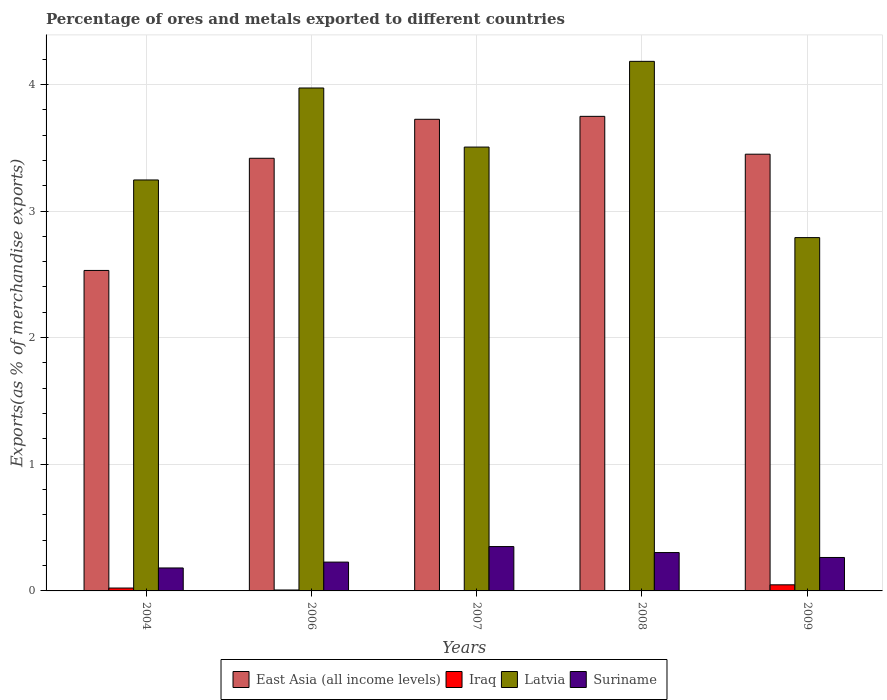How many different coloured bars are there?
Offer a very short reply. 4. What is the label of the 2nd group of bars from the left?
Offer a very short reply. 2006. What is the percentage of exports to different countries in Latvia in 2007?
Your response must be concise. 3.5. Across all years, what is the maximum percentage of exports to different countries in Suriname?
Your answer should be very brief. 0.35. Across all years, what is the minimum percentage of exports to different countries in Latvia?
Ensure brevity in your answer.  2.79. What is the total percentage of exports to different countries in East Asia (all income levels) in the graph?
Your answer should be compact. 16.87. What is the difference between the percentage of exports to different countries in Suriname in 2008 and that in 2009?
Keep it short and to the point. 0.04. What is the difference between the percentage of exports to different countries in Latvia in 2007 and the percentage of exports to different countries in Iraq in 2004?
Make the answer very short. 3.48. What is the average percentage of exports to different countries in East Asia (all income levels) per year?
Offer a terse response. 3.37. In the year 2006, what is the difference between the percentage of exports to different countries in Suriname and percentage of exports to different countries in Latvia?
Ensure brevity in your answer.  -3.74. What is the ratio of the percentage of exports to different countries in Suriname in 2006 to that in 2009?
Make the answer very short. 0.86. Is the percentage of exports to different countries in Latvia in 2007 less than that in 2009?
Your response must be concise. No. Is the difference between the percentage of exports to different countries in Suriname in 2007 and 2009 greater than the difference between the percentage of exports to different countries in Latvia in 2007 and 2009?
Offer a very short reply. No. What is the difference between the highest and the second highest percentage of exports to different countries in Iraq?
Your response must be concise. 0.03. What is the difference between the highest and the lowest percentage of exports to different countries in Latvia?
Your answer should be very brief. 1.39. What does the 1st bar from the left in 2009 represents?
Provide a succinct answer. East Asia (all income levels). What does the 4th bar from the right in 2009 represents?
Ensure brevity in your answer.  East Asia (all income levels). Is it the case that in every year, the sum of the percentage of exports to different countries in Iraq and percentage of exports to different countries in Latvia is greater than the percentage of exports to different countries in Suriname?
Provide a short and direct response. Yes. How many years are there in the graph?
Keep it short and to the point. 5. What is the difference between two consecutive major ticks on the Y-axis?
Give a very brief answer. 1. Does the graph contain any zero values?
Your response must be concise. No. How many legend labels are there?
Offer a terse response. 4. What is the title of the graph?
Offer a very short reply. Percentage of ores and metals exported to different countries. Does "Armenia" appear as one of the legend labels in the graph?
Keep it short and to the point. No. What is the label or title of the Y-axis?
Ensure brevity in your answer.  Exports(as % of merchandise exports). What is the Exports(as % of merchandise exports) in East Asia (all income levels) in 2004?
Offer a terse response. 2.53. What is the Exports(as % of merchandise exports) of Iraq in 2004?
Your response must be concise. 0.02. What is the Exports(as % of merchandise exports) in Latvia in 2004?
Give a very brief answer. 3.25. What is the Exports(as % of merchandise exports) in Suriname in 2004?
Your answer should be very brief. 0.18. What is the Exports(as % of merchandise exports) of East Asia (all income levels) in 2006?
Give a very brief answer. 3.42. What is the Exports(as % of merchandise exports) of Iraq in 2006?
Provide a short and direct response. 0.01. What is the Exports(as % of merchandise exports) of Latvia in 2006?
Your answer should be compact. 3.97. What is the Exports(as % of merchandise exports) of Suriname in 2006?
Give a very brief answer. 0.23. What is the Exports(as % of merchandise exports) of East Asia (all income levels) in 2007?
Offer a terse response. 3.72. What is the Exports(as % of merchandise exports) in Iraq in 2007?
Offer a very short reply. 9.249905308592759e-5. What is the Exports(as % of merchandise exports) of Latvia in 2007?
Provide a short and direct response. 3.5. What is the Exports(as % of merchandise exports) in Suriname in 2007?
Your answer should be very brief. 0.35. What is the Exports(as % of merchandise exports) in East Asia (all income levels) in 2008?
Your response must be concise. 3.75. What is the Exports(as % of merchandise exports) in Iraq in 2008?
Your response must be concise. 0. What is the Exports(as % of merchandise exports) of Latvia in 2008?
Your response must be concise. 4.18. What is the Exports(as % of merchandise exports) of Suriname in 2008?
Make the answer very short. 0.3. What is the Exports(as % of merchandise exports) in East Asia (all income levels) in 2009?
Your answer should be very brief. 3.45. What is the Exports(as % of merchandise exports) of Iraq in 2009?
Keep it short and to the point. 0.05. What is the Exports(as % of merchandise exports) in Latvia in 2009?
Provide a short and direct response. 2.79. What is the Exports(as % of merchandise exports) of Suriname in 2009?
Ensure brevity in your answer.  0.26. Across all years, what is the maximum Exports(as % of merchandise exports) of East Asia (all income levels)?
Give a very brief answer. 3.75. Across all years, what is the maximum Exports(as % of merchandise exports) of Iraq?
Offer a terse response. 0.05. Across all years, what is the maximum Exports(as % of merchandise exports) of Latvia?
Ensure brevity in your answer.  4.18. Across all years, what is the maximum Exports(as % of merchandise exports) of Suriname?
Your answer should be compact. 0.35. Across all years, what is the minimum Exports(as % of merchandise exports) in East Asia (all income levels)?
Keep it short and to the point. 2.53. Across all years, what is the minimum Exports(as % of merchandise exports) of Iraq?
Your answer should be very brief. 9.249905308592759e-5. Across all years, what is the minimum Exports(as % of merchandise exports) of Latvia?
Provide a short and direct response. 2.79. Across all years, what is the minimum Exports(as % of merchandise exports) of Suriname?
Your answer should be very brief. 0.18. What is the total Exports(as % of merchandise exports) of East Asia (all income levels) in the graph?
Provide a short and direct response. 16.87. What is the total Exports(as % of merchandise exports) of Iraq in the graph?
Your answer should be very brief. 0.08. What is the total Exports(as % of merchandise exports) of Latvia in the graph?
Provide a short and direct response. 17.69. What is the total Exports(as % of merchandise exports) in Suriname in the graph?
Your answer should be very brief. 1.33. What is the difference between the Exports(as % of merchandise exports) of East Asia (all income levels) in 2004 and that in 2006?
Offer a terse response. -0.89. What is the difference between the Exports(as % of merchandise exports) in Iraq in 2004 and that in 2006?
Give a very brief answer. 0.02. What is the difference between the Exports(as % of merchandise exports) of Latvia in 2004 and that in 2006?
Your response must be concise. -0.73. What is the difference between the Exports(as % of merchandise exports) of Suriname in 2004 and that in 2006?
Your answer should be very brief. -0.05. What is the difference between the Exports(as % of merchandise exports) in East Asia (all income levels) in 2004 and that in 2007?
Keep it short and to the point. -1.19. What is the difference between the Exports(as % of merchandise exports) in Iraq in 2004 and that in 2007?
Make the answer very short. 0.02. What is the difference between the Exports(as % of merchandise exports) of Latvia in 2004 and that in 2007?
Your answer should be compact. -0.26. What is the difference between the Exports(as % of merchandise exports) of Suriname in 2004 and that in 2007?
Your response must be concise. -0.17. What is the difference between the Exports(as % of merchandise exports) in East Asia (all income levels) in 2004 and that in 2008?
Your answer should be compact. -1.22. What is the difference between the Exports(as % of merchandise exports) in Iraq in 2004 and that in 2008?
Keep it short and to the point. 0.02. What is the difference between the Exports(as % of merchandise exports) in Latvia in 2004 and that in 2008?
Your answer should be very brief. -0.94. What is the difference between the Exports(as % of merchandise exports) in Suriname in 2004 and that in 2008?
Keep it short and to the point. -0.12. What is the difference between the Exports(as % of merchandise exports) in East Asia (all income levels) in 2004 and that in 2009?
Your answer should be compact. -0.92. What is the difference between the Exports(as % of merchandise exports) of Iraq in 2004 and that in 2009?
Make the answer very short. -0.03. What is the difference between the Exports(as % of merchandise exports) of Latvia in 2004 and that in 2009?
Offer a very short reply. 0.46. What is the difference between the Exports(as % of merchandise exports) of Suriname in 2004 and that in 2009?
Provide a short and direct response. -0.08. What is the difference between the Exports(as % of merchandise exports) in East Asia (all income levels) in 2006 and that in 2007?
Make the answer very short. -0.31. What is the difference between the Exports(as % of merchandise exports) of Iraq in 2006 and that in 2007?
Offer a very short reply. 0.01. What is the difference between the Exports(as % of merchandise exports) in Latvia in 2006 and that in 2007?
Your answer should be very brief. 0.47. What is the difference between the Exports(as % of merchandise exports) in Suriname in 2006 and that in 2007?
Offer a very short reply. -0.12. What is the difference between the Exports(as % of merchandise exports) in East Asia (all income levels) in 2006 and that in 2008?
Give a very brief answer. -0.33. What is the difference between the Exports(as % of merchandise exports) in Iraq in 2006 and that in 2008?
Keep it short and to the point. 0.01. What is the difference between the Exports(as % of merchandise exports) of Latvia in 2006 and that in 2008?
Keep it short and to the point. -0.21. What is the difference between the Exports(as % of merchandise exports) in Suriname in 2006 and that in 2008?
Keep it short and to the point. -0.08. What is the difference between the Exports(as % of merchandise exports) in East Asia (all income levels) in 2006 and that in 2009?
Give a very brief answer. -0.03. What is the difference between the Exports(as % of merchandise exports) in Iraq in 2006 and that in 2009?
Give a very brief answer. -0.04. What is the difference between the Exports(as % of merchandise exports) in Latvia in 2006 and that in 2009?
Offer a very short reply. 1.18. What is the difference between the Exports(as % of merchandise exports) in Suriname in 2006 and that in 2009?
Your answer should be compact. -0.04. What is the difference between the Exports(as % of merchandise exports) of East Asia (all income levels) in 2007 and that in 2008?
Offer a very short reply. -0.02. What is the difference between the Exports(as % of merchandise exports) in Iraq in 2007 and that in 2008?
Ensure brevity in your answer.  -0. What is the difference between the Exports(as % of merchandise exports) of Latvia in 2007 and that in 2008?
Keep it short and to the point. -0.68. What is the difference between the Exports(as % of merchandise exports) in Suriname in 2007 and that in 2008?
Ensure brevity in your answer.  0.05. What is the difference between the Exports(as % of merchandise exports) of East Asia (all income levels) in 2007 and that in 2009?
Offer a very short reply. 0.28. What is the difference between the Exports(as % of merchandise exports) in Iraq in 2007 and that in 2009?
Your answer should be compact. -0.05. What is the difference between the Exports(as % of merchandise exports) of Latvia in 2007 and that in 2009?
Make the answer very short. 0.71. What is the difference between the Exports(as % of merchandise exports) of Suriname in 2007 and that in 2009?
Offer a terse response. 0.09. What is the difference between the Exports(as % of merchandise exports) of East Asia (all income levels) in 2008 and that in 2009?
Provide a short and direct response. 0.3. What is the difference between the Exports(as % of merchandise exports) in Iraq in 2008 and that in 2009?
Provide a short and direct response. -0.05. What is the difference between the Exports(as % of merchandise exports) in Latvia in 2008 and that in 2009?
Offer a terse response. 1.39. What is the difference between the Exports(as % of merchandise exports) of Suriname in 2008 and that in 2009?
Provide a succinct answer. 0.04. What is the difference between the Exports(as % of merchandise exports) of East Asia (all income levels) in 2004 and the Exports(as % of merchandise exports) of Iraq in 2006?
Offer a terse response. 2.52. What is the difference between the Exports(as % of merchandise exports) of East Asia (all income levels) in 2004 and the Exports(as % of merchandise exports) of Latvia in 2006?
Your answer should be compact. -1.44. What is the difference between the Exports(as % of merchandise exports) in East Asia (all income levels) in 2004 and the Exports(as % of merchandise exports) in Suriname in 2006?
Offer a terse response. 2.3. What is the difference between the Exports(as % of merchandise exports) of Iraq in 2004 and the Exports(as % of merchandise exports) of Latvia in 2006?
Your answer should be compact. -3.95. What is the difference between the Exports(as % of merchandise exports) of Iraq in 2004 and the Exports(as % of merchandise exports) of Suriname in 2006?
Offer a terse response. -0.2. What is the difference between the Exports(as % of merchandise exports) of Latvia in 2004 and the Exports(as % of merchandise exports) of Suriname in 2006?
Give a very brief answer. 3.02. What is the difference between the Exports(as % of merchandise exports) in East Asia (all income levels) in 2004 and the Exports(as % of merchandise exports) in Iraq in 2007?
Make the answer very short. 2.53. What is the difference between the Exports(as % of merchandise exports) of East Asia (all income levels) in 2004 and the Exports(as % of merchandise exports) of Latvia in 2007?
Your answer should be very brief. -0.97. What is the difference between the Exports(as % of merchandise exports) of East Asia (all income levels) in 2004 and the Exports(as % of merchandise exports) of Suriname in 2007?
Keep it short and to the point. 2.18. What is the difference between the Exports(as % of merchandise exports) of Iraq in 2004 and the Exports(as % of merchandise exports) of Latvia in 2007?
Keep it short and to the point. -3.48. What is the difference between the Exports(as % of merchandise exports) in Iraq in 2004 and the Exports(as % of merchandise exports) in Suriname in 2007?
Give a very brief answer. -0.33. What is the difference between the Exports(as % of merchandise exports) of Latvia in 2004 and the Exports(as % of merchandise exports) of Suriname in 2007?
Provide a succinct answer. 2.89. What is the difference between the Exports(as % of merchandise exports) of East Asia (all income levels) in 2004 and the Exports(as % of merchandise exports) of Iraq in 2008?
Offer a very short reply. 2.53. What is the difference between the Exports(as % of merchandise exports) in East Asia (all income levels) in 2004 and the Exports(as % of merchandise exports) in Latvia in 2008?
Provide a succinct answer. -1.65. What is the difference between the Exports(as % of merchandise exports) in East Asia (all income levels) in 2004 and the Exports(as % of merchandise exports) in Suriname in 2008?
Ensure brevity in your answer.  2.23. What is the difference between the Exports(as % of merchandise exports) of Iraq in 2004 and the Exports(as % of merchandise exports) of Latvia in 2008?
Keep it short and to the point. -4.16. What is the difference between the Exports(as % of merchandise exports) in Iraq in 2004 and the Exports(as % of merchandise exports) in Suriname in 2008?
Keep it short and to the point. -0.28. What is the difference between the Exports(as % of merchandise exports) of Latvia in 2004 and the Exports(as % of merchandise exports) of Suriname in 2008?
Keep it short and to the point. 2.94. What is the difference between the Exports(as % of merchandise exports) in East Asia (all income levels) in 2004 and the Exports(as % of merchandise exports) in Iraq in 2009?
Offer a very short reply. 2.48. What is the difference between the Exports(as % of merchandise exports) in East Asia (all income levels) in 2004 and the Exports(as % of merchandise exports) in Latvia in 2009?
Your answer should be very brief. -0.26. What is the difference between the Exports(as % of merchandise exports) of East Asia (all income levels) in 2004 and the Exports(as % of merchandise exports) of Suriname in 2009?
Offer a terse response. 2.27. What is the difference between the Exports(as % of merchandise exports) in Iraq in 2004 and the Exports(as % of merchandise exports) in Latvia in 2009?
Your answer should be compact. -2.77. What is the difference between the Exports(as % of merchandise exports) in Iraq in 2004 and the Exports(as % of merchandise exports) in Suriname in 2009?
Offer a very short reply. -0.24. What is the difference between the Exports(as % of merchandise exports) in Latvia in 2004 and the Exports(as % of merchandise exports) in Suriname in 2009?
Keep it short and to the point. 2.98. What is the difference between the Exports(as % of merchandise exports) of East Asia (all income levels) in 2006 and the Exports(as % of merchandise exports) of Iraq in 2007?
Your response must be concise. 3.42. What is the difference between the Exports(as % of merchandise exports) of East Asia (all income levels) in 2006 and the Exports(as % of merchandise exports) of Latvia in 2007?
Provide a short and direct response. -0.09. What is the difference between the Exports(as % of merchandise exports) in East Asia (all income levels) in 2006 and the Exports(as % of merchandise exports) in Suriname in 2007?
Offer a very short reply. 3.07. What is the difference between the Exports(as % of merchandise exports) in Iraq in 2006 and the Exports(as % of merchandise exports) in Latvia in 2007?
Make the answer very short. -3.5. What is the difference between the Exports(as % of merchandise exports) of Iraq in 2006 and the Exports(as % of merchandise exports) of Suriname in 2007?
Give a very brief answer. -0.34. What is the difference between the Exports(as % of merchandise exports) in Latvia in 2006 and the Exports(as % of merchandise exports) in Suriname in 2007?
Your response must be concise. 3.62. What is the difference between the Exports(as % of merchandise exports) of East Asia (all income levels) in 2006 and the Exports(as % of merchandise exports) of Iraq in 2008?
Keep it short and to the point. 3.42. What is the difference between the Exports(as % of merchandise exports) of East Asia (all income levels) in 2006 and the Exports(as % of merchandise exports) of Latvia in 2008?
Provide a short and direct response. -0.77. What is the difference between the Exports(as % of merchandise exports) in East Asia (all income levels) in 2006 and the Exports(as % of merchandise exports) in Suriname in 2008?
Make the answer very short. 3.11. What is the difference between the Exports(as % of merchandise exports) of Iraq in 2006 and the Exports(as % of merchandise exports) of Latvia in 2008?
Give a very brief answer. -4.17. What is the difference between the Exports(as % of merchandise exports) in Iraq in 2006 and the Exports(as % of merchandise exports) in Suriname in 2008?
Your response must be concise. -0.3. What is the difference between the Exports(as % of merchandise exports) of Latvia in 2006 and the Exports(as % of merchandise exports) of Suriname in 2008?
Your response must be concise. 3.67. What is the difference between the Exports(as % of merchandise exports) of East Asia (all income levels) in 2006 and the Exports(as % of merchandise exports) of Iraq in 2009?
Your answer should be very brief. 3.37. What is the difference between the Exports(as % of merchandise exports) of East Asia (all income levels) in 2006 and the Exports(as % of merchandise exports) of Latvia in 2009?
Keep it short and to the point. 0.63. What is the difference between the Exports(as % of merchandise exports) in East Asia (all income levels) in 2006 and the Exports(as % of merchandise exports) in Suriname in 2009?
Your answer should be compact. 3.15. What is the difference between the Exports(as % of merchandise exports) of Iraq in 2006 and the Exports(as % of merchandise exports) of Latvia in 2009?
Your answer should be very brief. -2.78. What is the difference between the Exports(as % of merchandise exports) in Iraq in 2006 and the Exports(as % of merchandise exports) in Suriname in 2009?
Provide a short and direct response. -0.26. What is the difference between the Exports(as % of merchandise exports) of Latvia in 2006 and the Exports(as % of merchandise exports) of Suriname in 2009?
Keep it short and to the point. 3.71. What is the difference between the Exports(as % of merchandise exports) of East Asia (all income levels) in 2007 and the Exports(as % of merchandise exports) of Iraq in 2008?
Make the answer very short. 3.72. What is the difference between the Exports(as % of merchandise exports) of East Asia (all income levels) in 2007 and the Exports(as % of merchandise exports) of Latvia in 2008?
Keep it short and to the point. -0.46. What is the difference between the Exports(as % of merchandise exports) in East Asia (all income levels) in 2007 and the Exports(as % of merchandise exports) in Suriname in 2008?
Ensure brevity in your answer.  3.42. What is the difference between the Exports(as % of merchandise exports) of Iraq in 2007 and the Exports(as % of merchandise exports) of Latvia in 2008?
Make the answer very short. -4.18. What is the difference between the Exports(as % of merchandise exports) in Iraq in 2007 and the Exports(as % of merchandise exports) in Suriname in 2008?
Provide a short and direct response. -0.3. What is the difference between the Exports(as % of merchandise exports) of Latvia in 2007 and the Exports(as % of merchandise exports) of Suriname in 2008?
Keep it short and to the point. 3.2. What is the difference between the Exports(as % of merchandise exports) of East Asia (all income levels) in 2007 and the Exports(as % of merchandise exports) of Iraq in 2009?
Provide a short and direct response. 3.68. What is the difference between the Exports(as % of merchandise exports) of East Asia (all income levels) in 2007 and the Exports(as % of merchandise exports) of Latvia in 2009?
Provide a succinct answer. 0.93. What is the difference between the Exports(as % of merchandise exports) of East Asia (all income levels) in 2007 and the Exports(as % of merchandise exports) of Suriname in 2009?
Offer a terse response. 3.46. What is the difference between the Exports(as % of merchandise exports) in Iraq in 2007 and the Exports(as % of merchandise exports) in Latvia in 2009?
Provide a succinct answer. -2.79. What is the difference between the Exports(as % of merchandise exports) of Iraq in 2007 and the Exports(as % of merchandise exports) of Suriname in 2009?
Make the answer very short. -0.26. What is the difference between the Exports(as % of merchandise exports) in Latvia in 2007 and the Exports(as % of merchandise exports) in Suriname in 2009?
Your response must be concise. 3.24. What is the difference between the Exports(as % of merchandise exports) of East Asia (all income levels) in 2008 and the Exports(as % of merchandise exports) of Iraq in 2009?
Provide a succinct answer. 3.7. What is the difference between the Exports(as % of merchandise exports) of East Asia (all income levels) in 2008 and the Exports(as % of merchandise exports) of Latvia in 2009?
Make the answer very short. 0.96. What is the difference between the Exports(as % of merchandise exports) of East Asia (all income levels) in 2008 and the Exports(as % of merchandise exports) of Suriname in 2009?
Your answer should be very brief. 3.48. What is the difference between the Exports(as % of merchandise exports) of Iraq in 2008 and the Exports(as % of merchandise exports) of Latvia in 2009?
Keep it short and to the point. -2.79. What is the difference between the Exports(as % of merchandise exports) of Iraq in 2008 and the Exports(as % of merchandise exports) of Suriname in 2009?
Your answer should be very brief. -0.26. What is the difference between the Exports(as % of merchandise exports) of Latvia in 2008 and the Exports(as % of merchandise exports) of Suriname in 2009?
Provide a succinct answer. 3.92. What is the average Exports(as % of merchandise exports) in East Asia (all income levels) per year?
Ensure brevity in your answer.  3.37. What is the average Exports(as % of merchandise exports) in Iraq per year?
Provide a short and direct response. 0.02. What is the average Exports(as % of merchandise exports) of Latvia per year?
Your response must be concise. 3.54. What is the average Exports(as % of merchandise exports) of Suriname per year?
Your answer should be very brief. 0.27. In the year 2004, what is the difference between the Exports(as % of merchandise exports) of East Asia (all income levels) and Exports(as % of merchandise exports) of Iraq?
Keep it short and to the point. 2.51. In the year 2004, what is the difference between the Exports(as % of merchandise exports) of East Asia (all income levels) and Exports(as % of merchandise exports) of Latvia?
Your answer should be very brief. -0.71. In the year 2004, what is the difference between the Exports(as % of merchandise exports) in East Asia (all income levels) and Exports(as % of merchandise exports) in Suriname?
Offer a terse response. 2.35. In the year 2004, what is the difference between the Exports(as % of merchandise exports) in Iraq and Exports(as % of merchandise exports) in Latvia?
Offer a very short reply. -3.22. In the year 2004, what is the difference between the Exports(as % of merchandise exports) of Iraq and Exports(as % of merchandise exports) of Suriname?
Offer a terse response. -0.16. In the year 2004, what is the difference between the Exports(as % of merchandise exports) of Latvia and Exports(as % of merchandise exports) of Suriname?
Give a very brief answer. 3.06. In the year 2006, what is the difference between the Exports(as % of merchandise exports) in East Asia (all income levels) and Exports(as % of merchandise exports) in Iraq?
Your response must be concise. 3.41. In the year 2006, what is the difference between the Exports(as % of merchandise exports) of East Asia (all income levels) and Exports(as % of merchandise exports) of Latvia?
Make the answer very short. -0.56. In the year 2006, what is the difference between the Exports(as % of merchandise exports) in East Asia (all income levels) and Exports(as % of merchandise exports) in Suriname?
Offer a very short reply. 3.19. In the year 2006, what is the difference between the Exports(as % of merchandise exports) of Iraq and Exports(as % of merchandise exports) of Latvia?
Your response must be concise. -3.96. In the year 2006, what is the difference between the Exports(as % of merchandise exports) in Iraq and Exports(as % of merchandise exports) in Suriname?
Ensure brevity in your answer.  -0.22. In the year 2006, what is the difference between the Exports(as % of merchandise exports) in Latvia and Exports(as % of merchandise exports) in Suriname?
Your answer should be compact. 3.74. In the year 2007, what is the difference between the Exports(as % of merchandise exports) of East Asia (all income levels) and Exports(as % of merchandise exports) of Iraq?
Your response must be concise. 3.72. In the year 2007, what is the difference between the Exports(as % of merchandise exports) of East Asia (all income levels) and Exports(as % of merchandise exports) of Latvia?
Provide a short and direct response. 0.22. In the year 2007, what is the difference between the Exports(as % of merchandise exports) in East Asia (all income levels) and Exports(as % of merchandise exports) in Suriname?
Provide a short and direct response. 3.37. In the year 2007, what is the difference between the Exports(as % of merchandise exports) of Iraq and Exports(as % of merchandise exports) of Latvia?
Your answer should be very brief. -3.5. In the year 2007, what is the difference between the Exports(as % of merchandise exports) in Iraq and Exports(as % of merchandise exports) in Suriname?
Your answer should be very brief. -0.35. In the year 2007, what is the difference between the Exports(as % of merchandise exports) in Latvia and Exports(as % of merchandise exports) in Suriname?
Your response must be concise. 3.15. In the year 2008, what is the difference between the Exports(as % of merchandise exports) of East Asia (all income levels) and Exports(as % of merchandise exports) of Iraq?
Offer a terse response. 3.75. In the year 2008, what is the difference between the Exports(as % of merchandise exports) of East Asia (all income levels) and Exports(as % of merchandise exports) of Latvia?
Provide a succinct answer. -0.43. In the year 2008, what is the difference between the Exports(as % of merchandise exports) of East Asia (all income levels) and Exports(as % of merchandise exports) of Suriname?
Ensure brevity in your answer.  3.44. In the year 2008, what is the difference between the Exports(as % of merchandise exports) in Iraq and Exports(as % of merchandise exports) in Latvia?
Ensure brevity in your answer.  -4.18. In the year 2008, what is the difference between the Exports(as % of merchandise exports) of Iraq and Exports(as % of merchandise exports) of Suriname?
Keep it short and to the point. -0.3. In the year 2008, what is the difference between the Exports(as % of merchandise exports) in Latvia and Exports(as % of merchandise exports) in Suriname?
Make the answer very short. 3.88. In the year 2009, what is the difference between the Exports(as % of merchandise exports) in East Asia (all income levels) and Exports(as % of merchandise exports) in Iraq?
Offer a terse response. 3.4. In the year 2009, what is the difference between the Exports(as % of merchandise exports) of East Asia (all income levels) and Exports(as % of merchandise exports) of Latvia?
Keep it short and to the point. 0.66. In the year 2009, what is the difference between the Exports(as % of merchandise exports) in East Asia (all income levels) and Exports(as % of merchandise exports) in Suriname?
Offer a very short reply. 3.18. In the year 2009, what is the difference between the Exports(as % of merchandise exports) of Iraq and Exports(as % of merchandise exports) of Latvia?
Keep it short and to the point. -2.74. In the year 2009, what is the difference between the Exports(as % of merchandise exports) in Iraq and Exports(as % of merchandise exports) in Suriname?
Ensure brevity in your answer.  -0.22. In the year 2009, what is the difference between the Exports(as % of merchandise exports) in Latvia and Exports(as % of merchandise exports) in Suriname?
Ensure brevity in your answer.  2.53. What is the ratio of the Exports(as % of merchandise exports) of East Asia (all income levels) in 2004 to that in 2006?
Keep it short and to the point. 0.74. What is the ratio of the Exports(as % of merchandise exports) of Iraq in 2004 to that in 2006?
Keep it short and to the point. 3.09. What is the ratio of the Exports(as % of merchandise exports) of Latvia in 2004 to that in 2006?
Your answer should be very brief. 0.82. What is the ratio of the Exports(as % of merchandise exports) of Suriname in 2004 to that in 2006?
Offer a terse response. 0.8. What is the ratio of the Exports(as % of merchandise exports) of East Asia (all income levels) in 2004 to that in 2007?
Ensure brevity in your answer.  0.68. What is the ratio of the Exports(as % of merchandise exports) of Iraq in 2004 to that in 2007?
Keep it short and to the point. 245.55. What is the ratio of the Exports(as % of merchandise exports) in Latvia in 2004 to that in 2007?
Offer a terse response. 0.93. What is the ratio of the Exports(as % of merchandise exports) of Suriname in 2004 to that in 2007?
Offer a very short reply. 0.52. What is the ratio of the Exports(as % of merchandise exports) in East Asia (all income levels) in 2004 to that in 2008?
Ensure brevity in your answer.  0.68. What is the ratio of the Exports(as % of merchandise exports) in Iraq in 2004 to that in 2008?
Your answer should be very brief. 42.63. What is the ratio of the Exports(as % of merchandise exports) of Latvia in 2004 to that in 2008?
Your answer should be compact. 0.78. What is the ratio of the Exports(as % of merchandise exports) of Suriname in 2004 to that in 2008?
Ensure brevity in your answer.  0.6. What is the ratio of the Exports(as % of merchandise exports) of East Asia (all income levels) in 2004 to that in 2009?
Offer a very short reply. 0.73. What is the ratio of the Exports(as % of merchandise exports) in Iraq in 2004 to that in 2009?
Give a very brief answer. 0.47. What is the ratio of the Exports(as % of merchandise exports) of Latvia in 2004 to that in 2009?
Keep it short and to the point. 1.16. What is the ratio of the Exports(as % of merchandise exports) of Suriname in 2004 to that in 2009?
Keep it short and to the point. 0.69. What is the ratio of the Exports(as % of merchandise exports) in East Asia (all income levels) in 2006 to that in 2007?
Make the answer very short. 0.92. What is the ratio of the Exports(as % of merchandise exports) of Iraq in 2006 to that in 2007?
Ensure brevity in your answer.  79.37. What is the ratio of the Exports(as % of merchandise exports) of Latvia in 2006 to that in 2007?
Offer a very short reply. 1.13. What is the ratio of the Exports(as % of merchandise exports) in Suriname in 2006 to that in 2007?
Offer a very short reply. 0.65. What is the ratio of the Exports(as % of merchandise exports) of East Asia (all income levels) in 2006 to that in 2008?
Your answer should be compact. 0.91. What is the ratio of the Exports(as % of merchandise exports) of Iraq in 2006 to that in 2008?
Offer a terse response. 13.78. What is the ratio of the Exports(as % of merchandise exports) in Latvia in 2006 to that in 2008?
Provide a succinct answer. 0.95. What is the ratio of the Exports(as % of merchandise exports) in Suriname in 2006 to that in 2008?
Your response must be concise. 0.75. What is the ratio of the Exports(as % of merchandise exports) of East Asia (all income levels) in 2006 to that in 2009?
Keep it short and to the point. 0.99. What is the ratio of the Exports(as % of merchandise exports) of Iraq in 2006 to that in 2009?
Give a very brief answer. 0.15. What is the ratio of the Exports(as % of merchandise exports) in Latvia in 2006 to that in 2009?
Your response must be concise. 1.42. What is the ratio of the Exports(as % of merchandise exports) in Suriname in 2006 to that in 2009?
Ensure brevity in your answer.  0.86. What is the ratio of the Exports(as % of merchandise exports) in East Asia (all income levels) in 2007 to that in 2008?
Keep it short and to the point. 0.99. What is the ratio of the Exports(as % of merchandise exports) in Iraq in 2007 to that in 2008?
Provide a succinct answer. 0.17. What is the ratio of the Exports(as % of merchandise exports) of Latvia in 2007 to that in 2008?
Your answer should be compact. 0.84. What is the ratio of the Exports(as % of merchandise exports) of Suriname in 2007 to that in 2008?
Keep it short and to the point. 1.16. What is the ratio of the Exports(as % of merchandise exports) in East Asia (all income levels) in 2007 to that in 2009?
Offer a very short reply. 1.08. What is the ratio of the Exports(as % of merchandise exports) of Iraq in 2007 to that in 2009?
Keep it short and to the point. 0. What is the ratio of the Exports(as % of merchandise exports) in Latvia in 2007 to that in 2009?
Ensure brevity in your answer.  1.26. What is the ratio of the Exports(as % of merchandise exports) in Suriname in 2007 to that in 2009?
Offer a very short reply. 1.33. What is the ratio of the Exports(as % of merchandise exports) of East Asia (all income levels) in 2008 to that in 2009?
Provide a short and direct response. 1.09. What is the ratio of the Exports(as % of merchandise exports) of Iraq in 2008 to that in 2009?
Make the answer very short. 0.01. What is the ratio of the Exports(as % of merchandise exports) in Latvia in 2008 to that in 2009?
Give a very brief answer. 1.5. What is the ratio of the Exports(as % of merchandise exports) in Suriname in 2008 to that in 2009?
Ensure brevity in your answer.  1.15. What is the difference between the highest and the second highest Exports(as % of merchandise exports) in East Asia (all income levels)?
Ensure brevity in your answer.  0.02. What is the difference between the highest and the second highest Exports(as % of merchandise exports) of Iraq?
Your answer should be compact. 0.03. What is the difference between the highest and the second highest Exports(as % of merchandise exports) of Latvia?
Your answer should be compact. 0.21. What is the difference between the highest and the second highest Exports(as % of merchandise exports) of Suriname?
Ensure brevity in your answer.  0.05. What is the difference between the highest and the lowest Exports(as % of merchandise exports) of East Asia (all income levels)?
Provide a short and direct response. 1.22. What is the difference between the highest and the lowest Exports(as % of merchandise exports) in Iraq?
Your answer should be compact. 0.05. What is the difference between the highest and the lowest Exports(as % of merchandise exports) in Latvia?
Your answer should be very brief. 1.39. What is the difference between the highest and the lowest Exports(as % of merchandise exports) of Suriname?
Offer a very short reply. 0.17. 